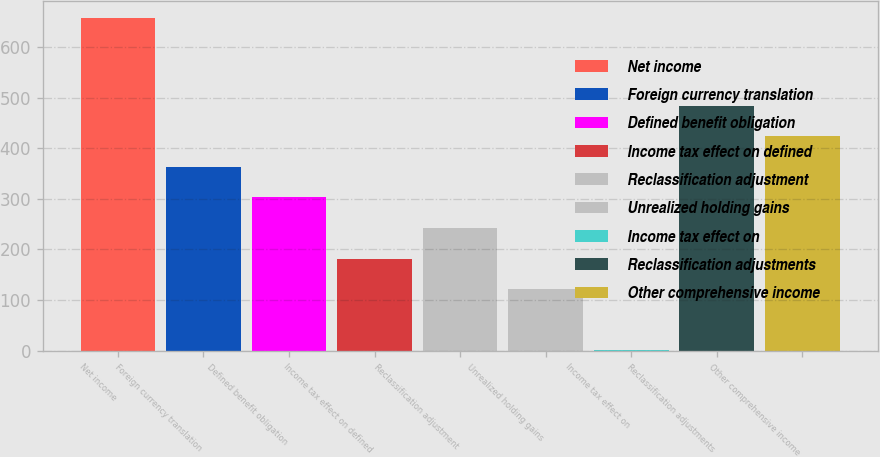Convert chart to OTSL. <chart><loc_0><loc_0><loc_500><loc_500><bar_chart><fcel>Net income<fcel>Foreign currency translation<fcel>Defined benefit obligation<fcel>Income tax effect on defined<fcel>Reclassification adjustment<fcel>Unrealized holding gains<fcel>Income tax effect on<fcel>Reclassification adjustments<fcel>Other comprehensive income<nl><fcel>657.99<fcel>363.44<fcel>302.95<fcel>181.97<fcel>242.46<fcel>121.48<fcel>0.5<fcel>484.42<fcel>423.93<nl></chart> 